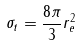<formula> <loc_0><loc_0><loc_500><loc_500>\sigma _ { t } = \frac { 8 \pi } { 3 } r _ { e } ^ { 2 }</formula> 